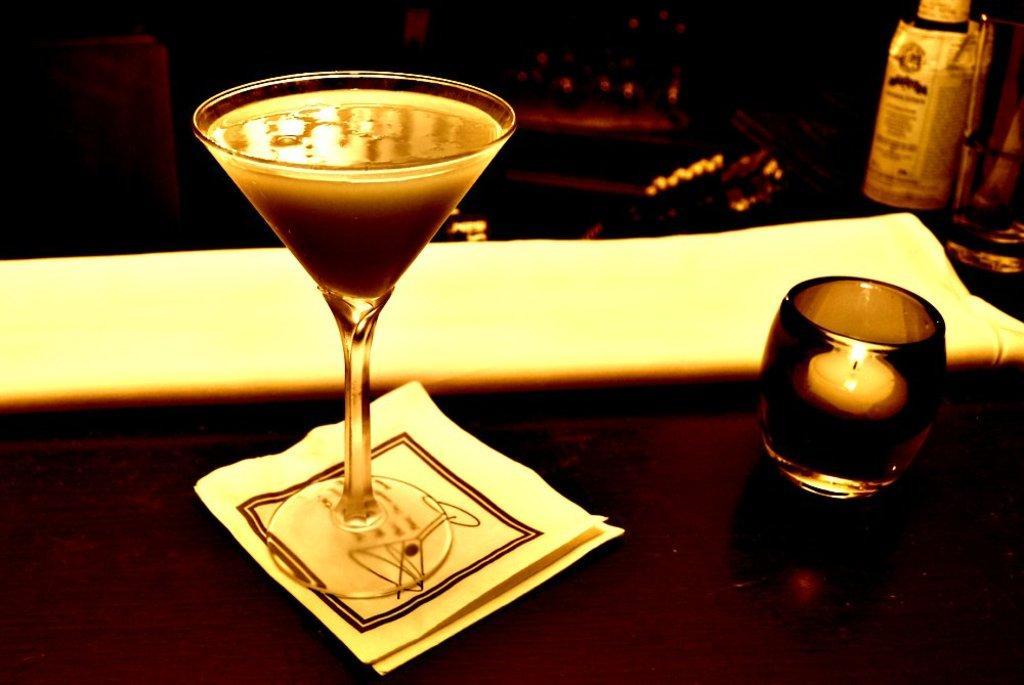How would you summarize this image in a sentence or two? On the left side, there is a glass, which is filled with drink placed on a brown colored surface. On the right side, there is a candlelight placed in a glass. This glass is placed on a brown colored surface. In the background, there is a bottle and there are other objects. And the background is dark in color. 